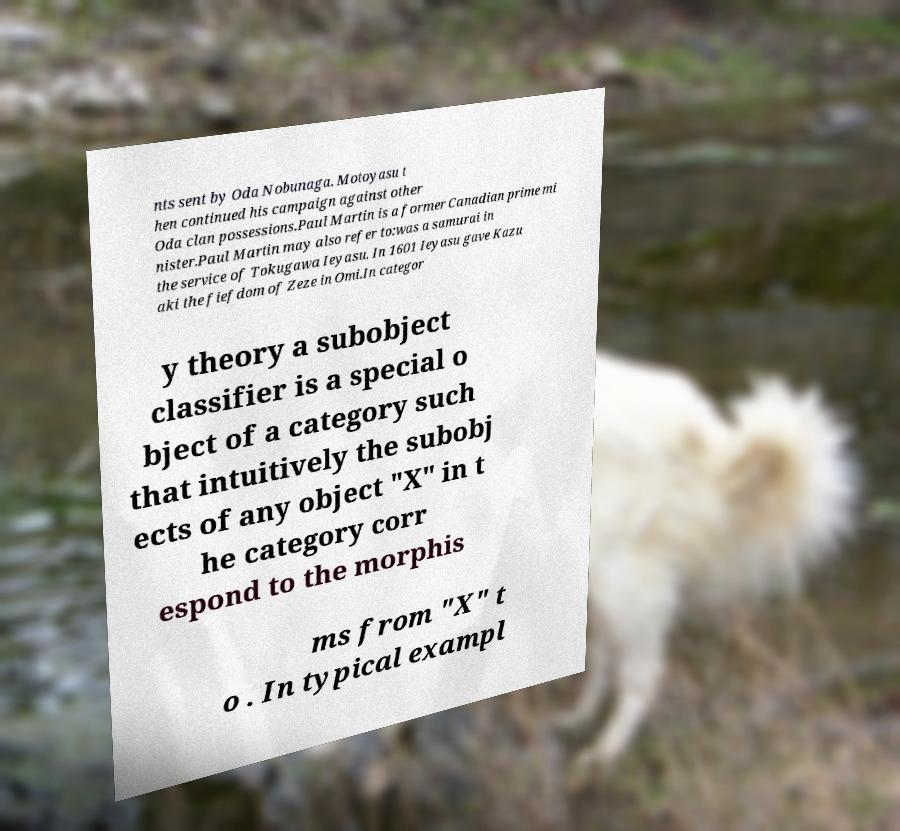For documentation purposes, I need the text within this image transcribed. Could you provide that? nts sent by Oda Nobunaga. Motoyasu t hen continued his campaign against other Oda clan possessions.Paul Martin is a former Canadian prime mi nister.Paul Martin may also refer to:was a samurai in the service of Tokugawa Ieyasu. In 1601 Ieyasu gave Kazu aki the fiefdom of Zeze in Omi.In categor y theory a subobject classifier is a special o bject of a category such that intuitively the subobj ects of any object "X" in t he category corr espond to the morphis ms from "X" t o . In typical exampl 